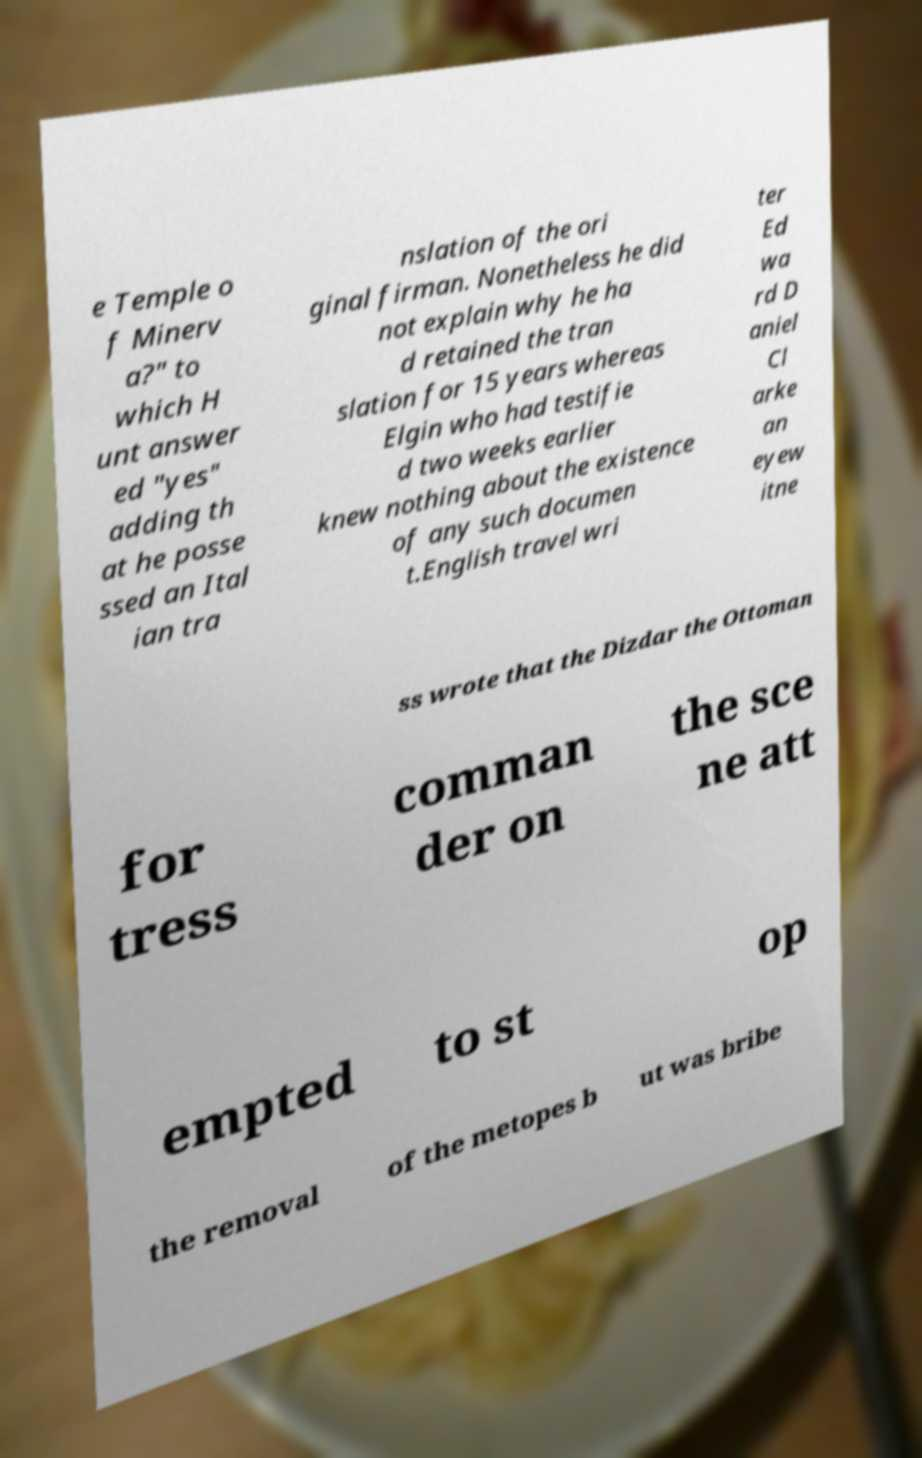Could you extract and type out the text from this image? e Temple o f Minerv a?" to which H unt answer ed "yes" adding th at he posse ssed an Ital ian tra nslation of the ori ginal firman. Nonetheless he did not explain why he ha d retained the tran slation for 15 years whereas Elgin who had testifie d two weeks earlier knew nothing about the existence of any such documen t.English travel wri ter Ed wa rd D aniel Cl arke an eyew itne ss wrote that the Dizdar the Ottoman for tress comman der on the sce ne att empted to st op the removal of the metopes b ut was bribe 